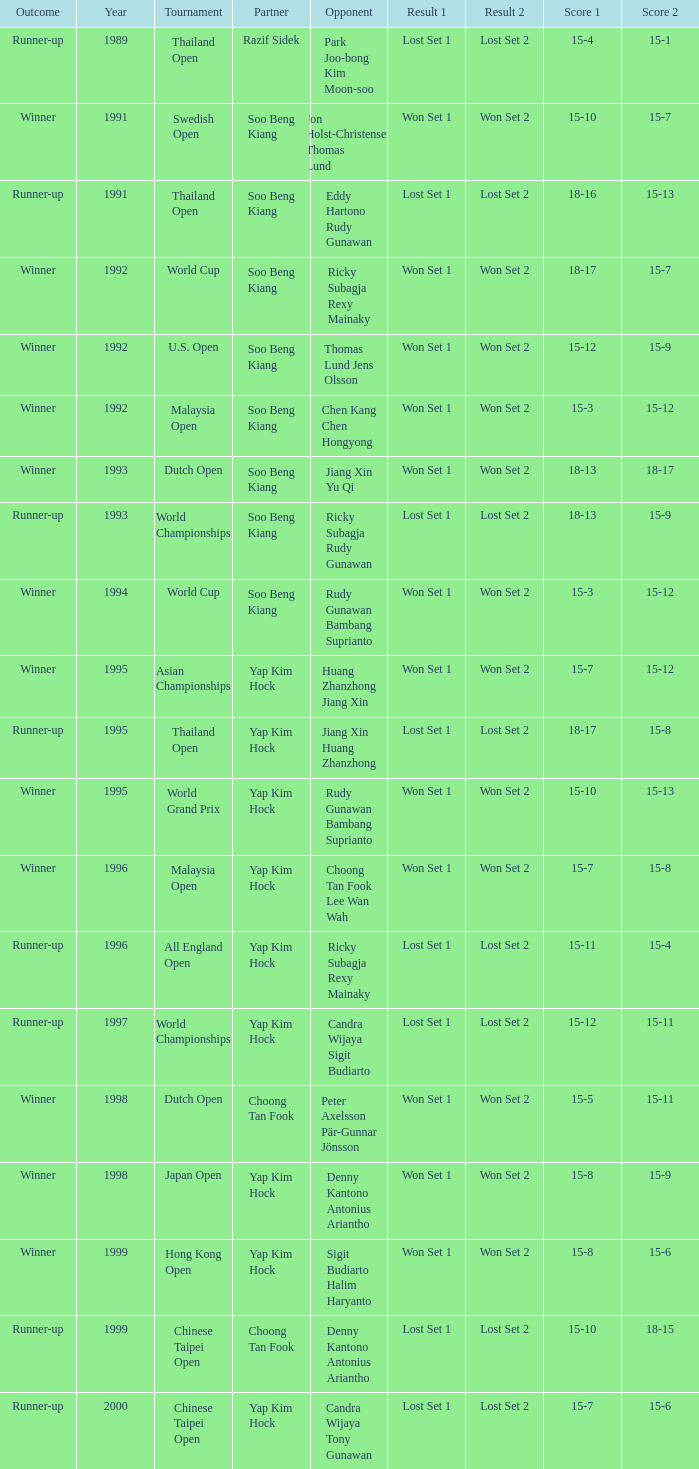Who was Choong Tan Fook's opponent in 1999? Denny Kantono Antonius Ariantho. 